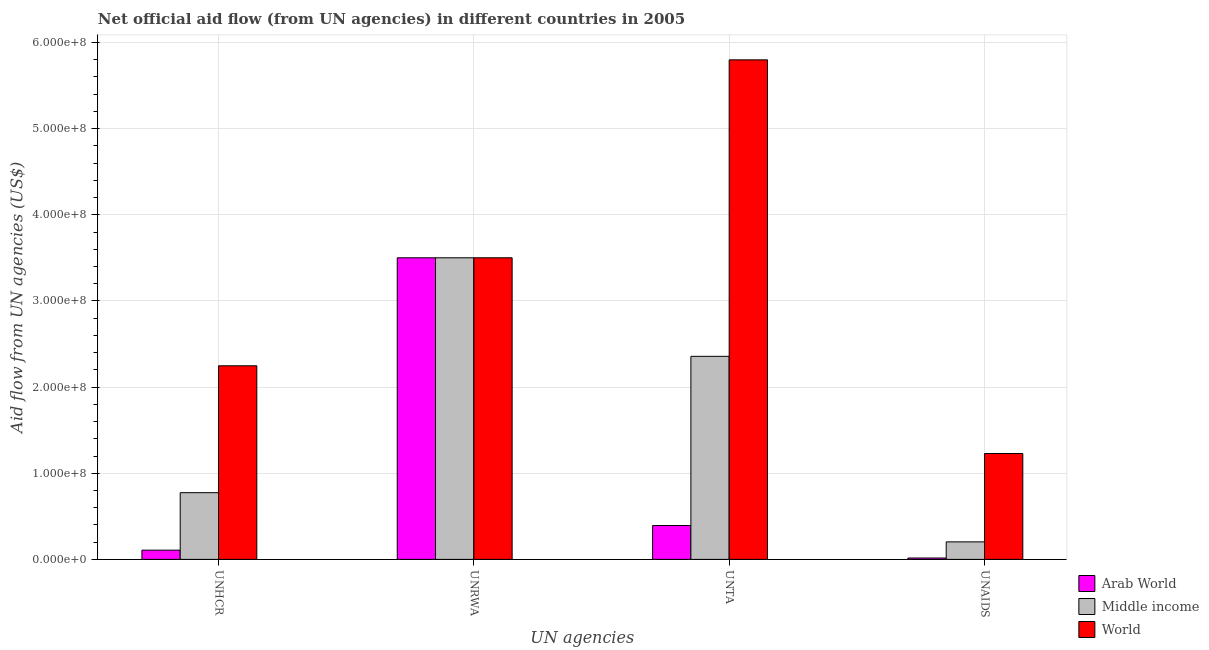How many groups of bars are there?
Keep it short and to the point. 4. What is the label of the 4th group of bars from the left?
Make the answer very short. UNAIDS. What is the amount of aid given by unrwa in Middle income?
Your response must be concise. 3.50e+08. Across all countries, what is the maximum amount of aid given by unaids?
Give a very brief answer. 1.23e+08. Across all countries, what is the minimum amount of aid given by unaids?
Offer a terse response. 1.60e+06. In which country was the amount of aid given by unrwa maximum?
Provide a short and direct response. Arab World. In which country was the amount of aid given by unhcr minimum?
Your response must be concise. Arab World. What is the total amount of aid given by unrwa in the graph?
Offer a very short reply. 1.05e+09. What is the difference between the amount of aid given by unrwa in Arab World and that in Middle income?
Give a very brief answer. 0. What is the difference between the amount of aid given by unrwa in Middle income and the amount of aid given by unhcr in Arab World?
Your answer should be very brief. 3.39e+08. What is the average amount of aid given by unrwa per country?
Your answer should be very brief. 3.50e+08. What is the difference between the amount of aid given by unaids and amount of aid given by unrwa in Arab World?
Keep it short and to the point. -3.49e+08. In how many countries, is the amount of aid given by unhcr greater than 60000000 US$?
Give a very brief answer. 2. What is the ratio of the amount of aid given by unhcr in Arab World to that in World?
Offer a terse response. 0.05. Is the amount of aid given by unaids in World less than that in Arab World?
Make the answer very short. No. What is the difference between the highest and the second highest amount of aid given by unhcr?
Offer a terse response. 1.47e+08. What is the difference between the highest and the lowest amount of aid given by unrwa?
Keep it short and to the point. 0. Is it the case that in every country, the sum of the amount of aid given by unhcr and amount of aid given by unaids is greater than the sum of amount of aid given by unrwa and amount of aid given by unta?
Your answer should be compact. No. What does the 1st bar from the left in UNHCR represents?
Give a very brief answer. Arab World. How many bars are there?
Give a very brief answer. 12. How many countries are there in the graph?
Make the answer very short. 3. What is the difference between two consecutive major ticks on the Y-axis?
Your answer should be very brief. 1.00e+08. Does the graph contain any zero values?
Ensure brevity in your answer.  No. Does the graph contain grids?
Keep it short and to the point. Yes. Where does the legend appear in the graph?
Provide a succinct answer. Bottom right. How many legend labels are there?
Your answer should be very brief. 3. What is the title of the graph?
Provide a short and direct response. Net official aid flow (from UN agencies) in different countries in 2005. Does "Nigeria" appear as one of the legend labels in the graph?
Your answer should be compact. No. What is the label or title of the X-axis?
Offer a terse response. UN agencies. What is the label or title of the Y-axis?
Provide a succinct answer. Aid flow from UN agencies (US$). What is the Aid flow from UN agencies (US$) in Arab World in UNHCR?
Make the answer very short. 1.07e+07. What is the Aid flow from UN agencies (US$) in Middle income in UNHCR?
Your answer should be compact. 7.74e+07. What is the Aid flow from UN agencies (US$) of World in UNHCR?
Provide a short and direct response. 2.25e+08. What is the Aid flow from UN agencies (US$) of Arab World in UNRWA?
Make the answer very short. 3.50e+08. What is the Aid flow from UN agencies (US$) of Middle income in UNRWA?
Give a very brief answer. 3.50e+08. What is the Aid flow from UN agencies (US$) in World in UNRWA?
Your answer should be very brief. 3.50e+08. What is the Aid flow from UN agencies (US$) in Arab World in UNTA?
Ensure brevity in your answer.  3.93e+07. What is the Aid flow from UN agencies (US$) of Middle income in UNTA?
Ensure brevity in your answer.  2.36e+08. What is the Aid flow from UN agencies (US$) in World in UNTA?
Provide a succinct answer. 5.80e+08. What is the Aid flow from UN agencies (US$) of Arab World in UNAIDS?
Your response must be concise. 1.60e+06. What is the Aid flow from UN agencies (US$) of Middle income in UNAIDS?
Offer a terse response. 2.03e+07. What is the Aid flow from UN agencies (US$) of World in UNAIDS?
Keep it short and to the point. 1.23e+08. Across all UN agencies, what is the maximum Aid flow from UN agencies (US$) in Arab World?
Offer a terse response. 3.50e+08. Across all UN agencies, what is the maximum Aid flow from UN agencies (US$) of Middle income?
Give a very brief answer. 3.50e+08. Across all UN agencies, what is the maximum Aid flow from UN agencies (US$) of World?
Offer a terse response. 5.80e+08. Across all UN agencies, what is the minimum Aid flow from UN agencies (US$) in Arab World?
Your response must be concise. 1.60e+06. Across all UN agencies, what is the minimum Aid flow from UN agencies (US$) of Middle income?
Your answer should be very brief. 2.03e+07. Across all UN agencies, what is the minimum Aid flow from UN agencies (US$) of World?
Offer a very short reply. 1.23e+08. What is the total Aid flow from UN agencies (US$) of Arab World in the graph?
Give a very brief answer. 4.02e+08. What is the total Aid flow from UN agencies (US$) of Middle income in the graph?
Your response must be concise. 6.84e+08. What is the total Aid flow from UN agencies (US$) in World in the graph?
Give a very brief answer. 1.28e+09. What is the difference between the Aid flow from UN agencies (US$) in Arab World in UNHCR and that in UNRWA?
Provide a short and direct response. -3.39e+08. What is the difference between the Aid flow from UN agencies (US$) of Middle income in UNHCR and that in UNRWA?
Offer a terse response. -2.73e+08. What is the difference between the Aid flow from UN agencies (US$) of World in UNHCR and that in UNRWA?
Your answer should be compact. -1.25e+08. What is the difference between the Aid flow from UN agencies (US$) in Arab World in UNHCR and that in UNTA?
Keep it short and to the point. -2.86e+07. What is the difference between the Aid flow from UN agencies (US$) in Middle income in UNHCR and that in UNTA?
Give a very brief answer. -1.58e+08. What is the difference between the Aid flow from UN agencies (US$) of World in UNHCR and that in UNTA?
Your answer should be very brief. -3.55e+08. What is the difference between the Aid flow from UN agencies (US$) of Arab World in UNHCR and that in UNAIDS?
Provide a short and direct response. 9.10e+06. What is the difference between the Aid flow from UN agencies (US$) in Middle income in UNHCR and that in UNAIDS?
Keep it short and to the point. 5.71e+07. What is the difference between the Aid flow from UN agencies (US$) in World in UNHCR and that in UNAIDS?
Give a very brief answer. 1.02e+08. What is the difference between the Aid flow from UN agencies (US$) of Arab World in UNRWA and that in UNTA?
Make the answer very short. 3.11e+08. What is the difference between the Aid flow from UN agencies (US$) of Middle income in UNRWA and that in UNTA?
Make the answer very short. 1.14e+08. What is the difference between the Aid flow from UN agencies (US$) in World in UNRWA and that in UNTA?
Give a very brief answer. -2.30e+08. What is the difference between the Aid flow from UN agencies (US$) in Arab World in UNRWA and that in UNAIDS?
Provide a short and direct response. 3.49e+08. What is the difference between the Aid flow from UN agencies (US$) of Middle income in UNRWA and that in UNAIDS?
Make the answer very short. 3.30e+08. What is the difference between the Aid flow from UN agencies (US$) of World in UNRWA and that in UNAIDS?
Your answer should be compact. 2.27e+08. What is the difference between the Aid flow from UN agencies (US$) of Arab World in UNTA and that in UNAIDS?
Provide a short and direct response. 3.77e+07. What is the difference between the Aid flow from UN agencies (US$) in Middle income in UNTA and that in UNAIDS?
Make the answer very short. 2.15e+08. What is the difference between the Aid flow from UN agencies (US$) in World in UNTA and that in UNAIDS?
Keep it short and to the point. 4.57e+08. What is the difference between the Aid flow from UN agencies (US$) of Arab World in UNHCR and the Aid flow from UN agencies (US$) of Middle income in UNRWA?
Make the answer very short. -3.39e+08. What is the difference between the Aid flow from UN agencies (US$) in Arab World in UNHCR and the Aid flow from UN agencies (US$) in World in UNRWA?
Your response must be concise. -3.39e+08. What is the difference between the Aid flow from UN agencies (US$) in Middle income in UNHCR and the Aid flow from UN agencies (US$) in World in UNRWA?
Your answer should be very brief. -2.73e+08. What is the difference between the Aid flow from UN agencies (US$) in Arab World in UNHCR and the Aid flow from UN agencies (US$) in Middle income in UNTA?
Provide a short and direct response. -2.25e+08. What is the difference between the Aid flow from UN agencies (US$) in Arab World in UNHCR and the Aid flow from UN agencies (US$) in World in UNTA?
Offer a terse response. -5.69e+08. What is the difference between the Aid flow from UN agencies (US$) in Middle income in UNHCR and the Aid flow from UN agencies (US$) in World in UNTA?
Give a very brief answer. -5.02e+08. What is the difference between the Aid flow from UN agencies (US$) of Arab World in UNHCR and the Aid flow from UN agencies (US$) of Middle income in UNAIDS?
Make the answer very short. -9.63e+06. What is the difference between the Aid flow from UN agencies (US$) in Arab World in UNHCR and the Aid flow from UN agencies (US$) in World in UNAIDS?
Provide a short and direct response. -1.12e+08. What is the difference between the Aid flow from UN agencies (US$) of Middle income in UNHCR and the Aid flow from UN agencies (US$) of World in UNAIDS?
Keep it short and to the point. -4.55e+07. What is the difference between the Aid flow from UN agencies (US$) of Arab World in UNRWA and the Aid flow from UN agencies (US$) of Middle income in UNTA?
Your response must be concise. 1.14e+08. What is the difference between the Aid flow from UN agencies (US$) of Arab World in UNRWA and the Aid flow from UN agencies (US$) of World in UNTA?
Your answer should be compact. -2.30e+08. What is the difference between the Aid flow from UN agencies (US$) of Middle income in UNRWA and the Aid flow from UN agencies (US$) of World in UNTA?
Your response must be concise. -2.30e+08. What is the difference between the Aid flow from UN agencies (US$) of Arab World in UNRWA and the Aid flow from UN agencies (US$) of Middle income in UNAIDS?
Your response must be concise. 3.30e+08. What is the difference between the Aid flow from UN agencies (US$) of Arab World in UNRWA and the Aid flow from UN agencies (US$) of World in UNAIDS?
Ensure brevity in your answer.  2.27e+08. What is the difference between the Aid flow from UN agencies (US$) of Middle income in UNRWA and the Aid flow from UN agencies (US$) of World in UNAIDS?
Give a very brief answer. 2.27e+08. What is the difference between the Aid flow from UN agencies (US$) in Arab World in UNTA and the Aid flow from UN agencies (US$) in Middle income in UNAIDS?
Offer a terse response. 1.90e+07. What is the difference between the Aid flow from UN agencies (US$) of Arab World in UNTA and the Aid flow from UN agencies (US$) of World in UNAIDS?
Offer a very short reply. -8.36e+07. What is the difference between the Aid flow from UN agencies (US$) of Middle income in UNTA and the Aid flow from UN agencies (US$) of World in UNAIDS?
Offer a terse response. 1.13e+08. What is the average Aid flow from UN agencies (US$) in Arab World per UN agencies?
Ensure brevity in your answer.  1.00e+08. What is the average Aid flow from UN agencies (US$) in Middle income per UN agencies?
Offer a terse response. 1.71e+08. What is the average Aid flow from UN agencies (US$) of World per UN agencies?
Keep it short and to the point. 3.19e+08. What is the difference between the Aid flow from UN agencies (US$) in Arab World and Aid flow from UN agencies (US$) in Middle income in UNHCR?
Give a very brief answer. -6.67e+07. What is the difference between the Aid flow from UN agencies (US$) of Arab World and Aid flow from UN agencies (US$) of World in UNHCR?
Make the answer very short. -2.14e+08. What is the difference between the Aid flow from UN agencies (US$) of Middle income and Aid flow from UN agencies (US$) of World in UNHCR?
Your response must be concise. -1.47e+08. What is the difference between the Aid flow from UN agencies (US$) in Arab World and Aid flow from UN agencies (US$) in Middle income in UNRWA?
Provide a succinct answer. 0. What is the difference between the Aid flow from UN agencies (US$) in Middle income and Aid flow from UN agencies (US$) in World in UNRWA?
Provide a short and direct response. 0. What is the difference between the Aid flow from UN agencies (US$) of Arab World and Aid flow from UN agencies (US$) of Middle income in UNTA?
Provide a succinct answer. -1.96e+08. What is the difference between the Aid flow from UN agencies (US$) of Arab World and Aid flow from UN agencies (US$) of World in UNTA?
Offer a very short reply. -5.41e+08. What is the difference between the Aid flow from UN agencies (US$) in Middle income and Aid flow from UN agencies (US$) in World in UNTA?
Your answer should be compact. -3.44e+08. What is the difference between the Aid flow from UN agencies (US$) in Arab World and Aid flow from UN agencies (US$) in Middle income in UNAIDS?
Your answer should be very brief. -1.87e+07. What is the difference between the Aid flow from UN agencies (US$) in Arab World and Aid flow from UN agencies (US$) in World in UNAIDS?
Your response must be concise. -1.21e+08. What is the difference between the Aid flow from UN agencies (US$) of Middle income and Aid flow from UN agencies (US$) of World in UNAIDS?
Provide a short and direct response. -1.03e+08. What is the ratio of the Aid flow from UN agencies (US$) of Arab World in UNHCR to that in UNRWA?
Keep it short and to the point. 0.03. What is the ratio of the Aid flow from UN agencies (US$) in Middle income in UNHCR to that in UNRWA?
Give a very brief answer. 0.22. What is the ratio of the Aid flow from UN agencies (US$) in World in UNHCR to that in UNRWA?
Your response must be concise. 0.64. What is the ratio of the Aid flow from UN agencies (US$) of Arab World in UNHCR to that in UNTA?
Provide a succinct answer. 0.27. What is the ratio of the Aid flow from UN agencies (US$) of Middle income in UNHCR to that in UNTA?
Give a very brief answer. 0.33. What is the ratio of the Aid flow from UN agencies (US$) in World in UNHCR to that in UNTA?
Your answer should be compact. 0.39. What is the ratio of the Aid flow from UN agencies (US$) of Arab World in UNHCR to that in UNAIDS?
Provide a short and direct response. 6.69. What is the ratio of the Aid flow from UN agencies (US$) in Middle income in UNHCR to that in UNAIDS?
Give a very brief answer. 3.81. What is the ratio of the Aid flow from UN agencies (US$) in World in UNHCR to that in UNAIDS?
Your response must be concise. 1.83. What is the ratio of the Aid flow from UN agencies (US$) of Arab World in UNRWA to that in UNTA?
Your answer should be compact. 8.9. What is the ratio of the Aid flow from UN agencies (US$) in Middle income in UNRWA to that in UNTA?
Offer a terse response. 1.49. What is the ratio of the Aid flow from UN agencies (US$) of World in UNRWA to that in UNTA?
Provide a short and direct response. 0.6. What is the ratio of the Aid flow from UN agencies (US$) of Arab World in UNRWA to that in UNAIDS?
Your response must be concise. 218.82. What is the ratio of the Aid flow from UN agencies (US$) in Middle income in UNRWA to that in UNAIDS?
Offer a very short reply. 17.22. What is the ratio of the Aid flow from UN agencies (US$) in World in UNRWA to that in UNAIDS?
Your response must be concise. 2.85. What is the ratio of the Aid flow from UN agencies (US$) of Arab World in UNTA to that in UNAIDS?
Keep it short and to the point. 24.57. What is the ratio of the Aid flow from UN agencies (US$) of Middle income in UNTA to that in UNAIDS?
Your answer should be very brief. 11.59. What is the ratio of the Aid flow from UN agencies (US$) in World in UNTA to that in UNAIDS?
Ensure brevity in your answer.  4.72. What is the difference between the highest and the second highest Aid flow from UN agencies (US$) of Arab World?
Provide a short and direct response. 3.11e+08. What is the difference between the highest and the second highest Aid flow from UN agencies (US$) in Middle income?
Your answer should be very brief. 1.14e+08. What is the difference between the highest and the second highest Aid flow from UN agencies (US$) in World?
Give a very brief answer. 2.30e+08. What is the difference between the highest and the lowest Aid flow from UN agencies (US$) of Arab World?
Your answer should be compact. 3.49e+08. What is the difference between the highest and the lowest Aid flow from UN agencies (US$) in Middle income?
Your answer should be very brief. 3.30e+08. What is the difference between the highest and the lowest Aid flow from UN agencies (US$) in World?
Provide a succinct answer. 4.57e+08. 